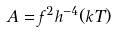Convert formula to latex. <formula><loc_0><loc_0><loc_500><loc_500>A = f ^ { 2 } h ^ { - 4 } ( k T )</formula> 